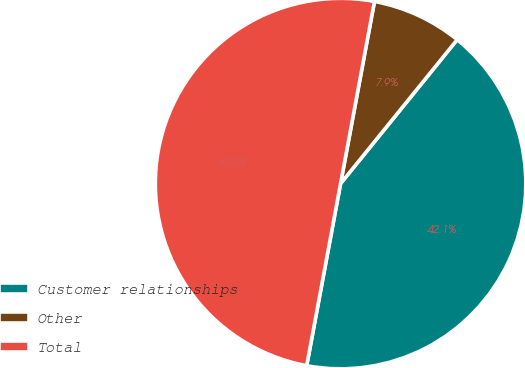Convert chart to OTSL. <chart><loc_0><loc_0><loc_500><loc_500><pie_chart><fcel>Customer relationships<fcel>Other<fcel>Total<nl><fcel>42.09%<fcel>7.91%<fcel>50.0%<nl></chart> 